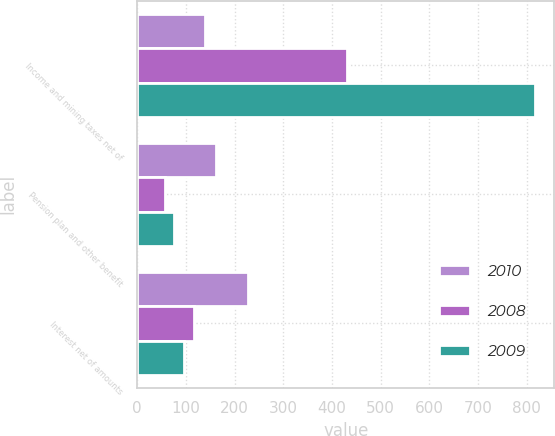Convert chart to OTSL. <chart><loc_0><loc_0><loc_500><loc_500><stacked_bar_chart><ecel><fcel>Income and mining taxes net of<fcel>Pension plan and other benefit<fcel>Interest net of amounts<nl><fcel>2010<fcel>140<fcel>163<fcel>228<nl><fcel>2008<fcel>431<fcel>58<fcel>117<nl><fcel>2009<fcel>816<fcel>76<fcel>96<nl></chart> 